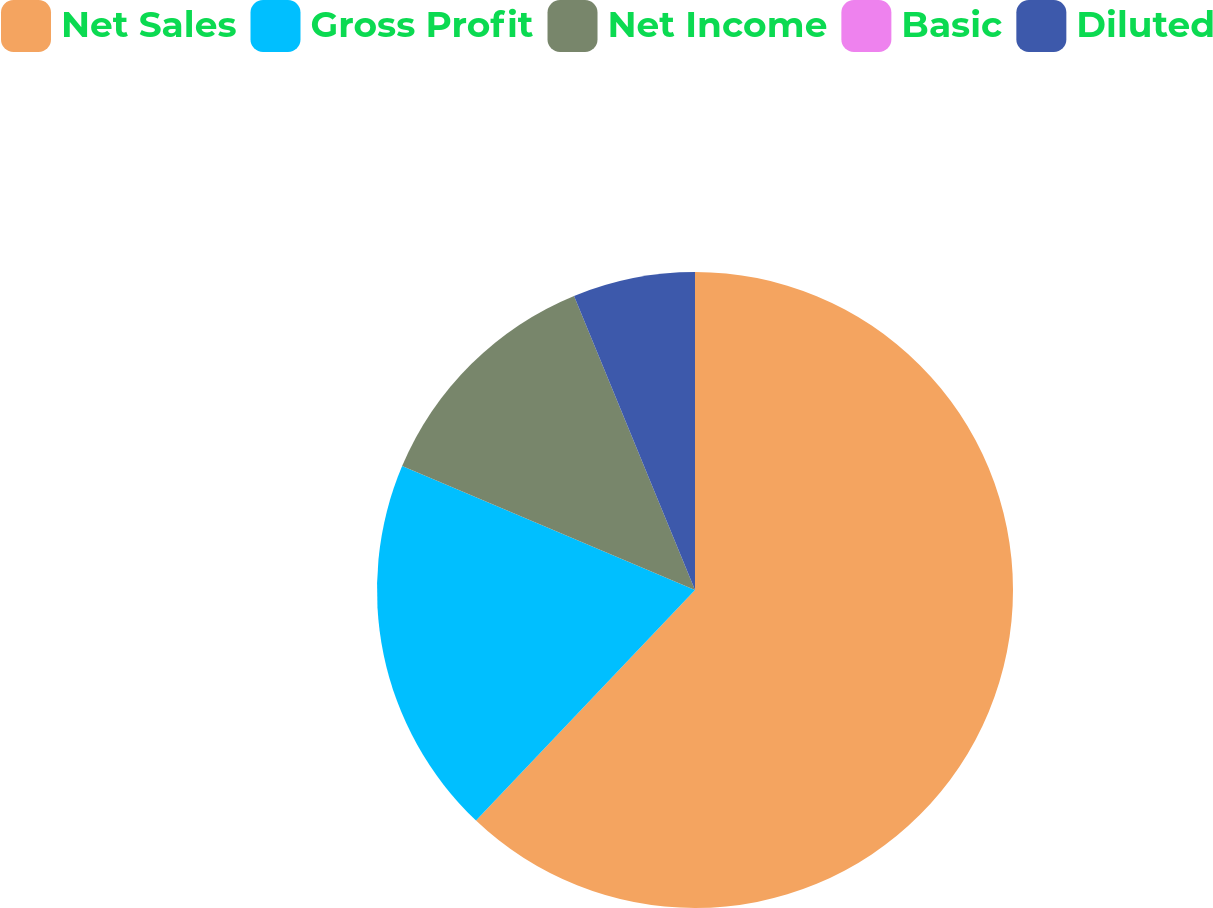Convert chart. <chart><loc_0><loc_0><loc_500><loc_500><pie_chart><fcel>Net Sales<fcel>Gross Profit<fcel>Net Income<fcel>Basic<fcel>Diluted<nl><fcel>62.09%<fcel>19.28%<fcel>12.42%<fcel>0.0%<fcel>6.21%<nl></chart> 